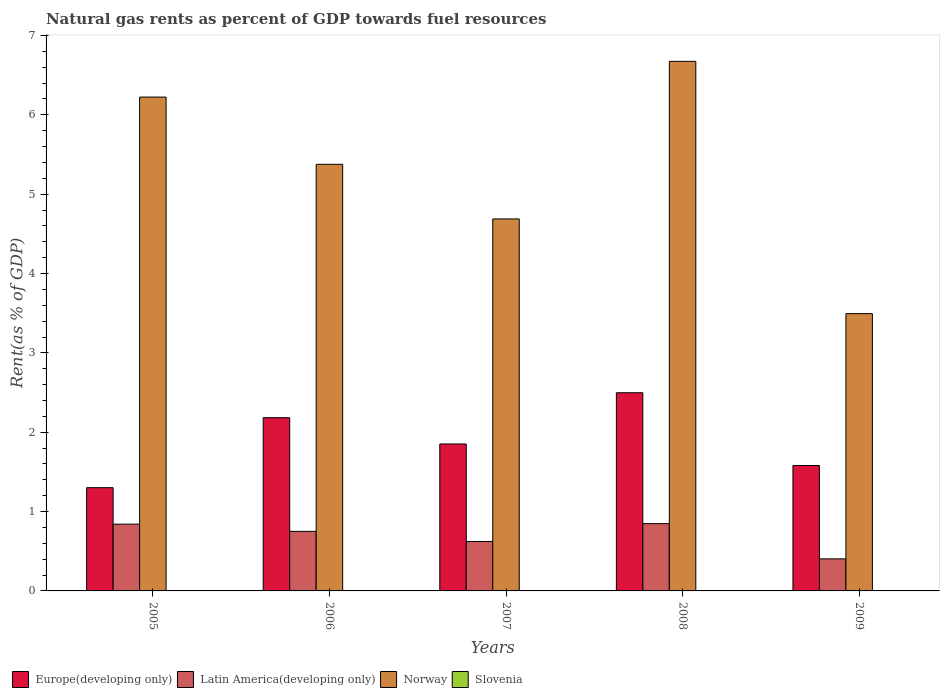How many different coloured bars are there?
Give a very brief answer. 4. How many groups of bars are there?
Offer a terse response. 5. Are the number of bars on each tick of the X-axis equal?
Ensure brevity in your answer.  Yes. What is the label of the 4th group of bars from the left?
Provide a short and direct response. 2008. What is the matural gas rent in Norway in 2008?
Make the answer very short. 6.67. Across all years, what is the maximum matural gas rent in Latin America(developing only)?
Ensure brevity in your answer.  0.85. Across all years, what is the minimum matural gas rent in Latin America(developing only)?
Your answer should be very brief. 0.4. What is the total matural gas rent in Slovenia in the graph?
Make the answer very short. 0.01. What is the difference between the matural gas rent in Norway in 2006 and that in 2008?
Your answer should be compact. -1.3. What is the difference between the matural gas rent in Europe(developing only) in 2008 and the matural gas rent in Slovenia in 2009?
Ensure brevity in your answer.  2.5. What is the average matural gas rent in Latin America(developing only) per year?
Your response must be concise. 0.69. In the year 2009, what is the difference between the matural gas rent in Europe(developing only) and matural gas rent in Latin America(developing only)?
Make the answer very short. 1.18. In how many years, is the matural gas rent in Latin America(developing only) greater than 3.4 %?
Give a very brief answer. 0. What is the ratio of the matural gas rent in Slovenia in 2006 to that in 2007?
Ensure brevity in your answer.  1.64. Is the difference between the matural gas rent in Europe(developing only) in 2006 and 2009 greater than the difference between the matural gas rent in Latin America(developing only) in 2006 and 2009?
Ensure brevity in your answer.  Yes. What is the difference between the highest and the second highest matural gas rent in Europe(developing only)?
Keep it short and to the point. 0.31. What is the difference between the highest and the lowest matural gas rent in Norway?
Keep it short and to the point. 3.18. In how many years, is the matural gas rent in Slovenia greater than the average matural gas rent in Slovenia taken over all years?
Offer a very short reply. 3. Is the sum of the matural gas rent in Latin America(developing only) in 2007 and 2009 greater than the maximum matural gas rent in Europe(developing only) across all years?
Offer a terse response. No. What does the 4th bar from the right in 2009 represents?
Offer a very short reply. Europe(developing only). Is it the case that in every year, the sum of the matural gas rent in Norway and matural gas rent in Slovenia is greater than the matural gas rent in Europe(developing only)?
Offer a terse response. Yes. How many years are there in the graph?
Ensure brevity in your answer.  5. What is the difference between two consecutive major ticks on the Y-axis?
Offer a terse response. 1. Does the graph contain any zero values?
Your response must be concise. No. Does the graph contain grids?
Offer a terse response. No. How are the legend labels stacked?
Provide a succinct answer. Horizontal. What is the title of the graph?
Give a very brief answer. Natural gas rents as percent of GDP towards fuel resources. What is the label or title of the Y-axis?
Your response must be concise. Rent(as % of GDP). What is the Rent(as % of GDP) of Europe(developing only) in 2005?
Offer a terse response. 1.3. What is the Rent(as % of GDP) of Latin America(developing only) in 2005?
Provide a short and direct response. 0.84. What is the Rent(as % of GDP) of Norway in 2005?
Offer a very short reply. 6.22. What is the Rent(as % of GDP) in Slovenia in 2005?
Ensure brevity in your answer.  0. What is the Rent(as % of GDP) in Europe(developing only) in 2006?
Keep it short and to the point. 2.18. What is the Rent(as % of GDP) in Latin America(developing only) in 2006?
Offer a terse response. 0.75. What is the Rent(as % of GDP) of Norway in 2006?
Provide a succinct answer. 5.38. What is the Rent(as % of GDP) of Slovenia in 2006?
Give a very brief answer. 0. What is the Rent(as % of GDP) in Europe(developing only) in 2007?
Keep it short and to the point. 1.85. What is the Rent(as % of GDP) of Latin America(developing only) in 2007?
Provide a succinct answer. 0.62. What is the Rent(as % of GDP) of Norway in 2007?
Your response must be concise. 4.69. What is the Rent(as % of GDP) in Slovenia in 2007?
Your response must be concise. 0. What is the Rent(as % of GDP) of Europe(developing only) in 2008?
Offer a very short reply. 2.5. What is the Rent(as % of GDP) of Latin America(developing only) in 2008?
Provide a succinct answer. 0.85. What is the Rent(as % of GDP) of Norway in 2008?
Your answer should be compact. 6.67. What is the Rent(as % of GDP) of Slovenia in 2008?
Keep it short and to the point. 0. What is the Rent(as % of GDP) of Europe(developing only) in 2009?
Ensure brevity in your answer.  1.58. What is the Rent(as % of GDP) in Latin America(developing only) in 2009?
Offer a terse response. 0.4. What is the Rent(as % of GDP) of Norway in 2009?
Your answer should be very brief. 3.49. What is the Rent(as % of GDP) in Slovenia in 2009?
Provide a short and direct response. 0. Across all years, what is the maximum Rent(as % of GDP) in Europe(developing only)?
Keep it short and to the point. 2.5. Across all years, what is the maximum Rent(as % of GDP) in Latin America(developing only)?
Ensure brevity in your answer.  0.85. Across all years, what is the maximum Rent(as % of GDP) of Norway?
Offer a very short reply. 6.67. Across all years, what is the maximum Rent(as % of GDP) in Slovenia?
Keep it short and to the point. 0. Across all years, what is the minimum Rent(as % of GDP) of Europe(developing only)?
Your answer should be very brief. 1.3. Across all years, what is the minimum Rent(as % of GDP) in Latin America(developing only)?
Your response must be concise. 0.4. Across all years, what is the minimum Rent(as % of GDP) in Norway?
Provide a succinct answer. 3.49. Across all years, what is the minimum Rent(as % of GDP) in Slovenia?
Your response must be concise. 0. What is the total Rent(as % of GDP) in Europe(developing only) in the graph?
Offer a terse response. 9.42. What is the total Rent(as % of GDP) of Latin America(developing only) in the graph?
Provide a short and direct response. 3.47. What is the total Rent(as % of GDP) of Norway in the graph?
Make the answer very short. 26.46. What is the total Rent(as % of GDP) in Slovenia in the graph?
Offer a terse response. 0.01. What is the difference between the Rent(as % of GDP) of Europe(developing only) in 2005 and that in 2006?
Offer a terse response. -0.88. What is the difference between the Rent(as % of GDP) of Latin America(developing only) in 2005 and that in 2006?
Your answer should be compact. 0.09. What is the difference between the Rent(as % of GDP) in Norway in 2005 and that in 2006?
Make the answer very short. 0.85. What is the difference between the Rent(as % of GDP) in Slovenia in 2005 and that in 2006?
Provide a succinct answer. 0. What is the difference between the Rent(as % of GDP) of Europe(developing only) in 2005 and that in 2007?
Your response must be concise. -0.55. What is the difference between the Rent(as % of GDP) in Latin America(developing only) in 2005 and that in 2007?
Offer a terse response. 0.22. What is the difference between the Rent(as % of GDP) of Norway in 2005 and that in 2007?
Ensure brevity in your answer.  1.54. What is the difference between the Rent(as % of GDP) of Slovenia in 2005 and that in 2007?
Your answer should be compact. 0. What is the difference between the Rent(as % of GDP) of Europe(developing only) in 2005 and that in 2008?
Offer a very short reply. -1.2. What is the difference between the Rent(as % of GDP) in Latin America(developing only) in 2005 and that in 2008?
Your answer should be very brief. -0.01. What is the difference between the Rent(as % of GDP) in Norway in 2005 and that in 2008?
Your response must be concise. -0.45. What is the difference between the Rent(as % of GDP) of Slovenia in 2005 and that in 2008?
Ensure brevity in your answer.  0. What is the difference between the Rent(as % of GDP) of Europe(developing only) in 2005 and that in 2009?
Ensure brevity in your answer.  -0.28. What is the difference between the Rent(as % of GDP) in Latin America(developing only) in 2005 and that in 2009?
Provide a succinct answer. 0.44. What is the difference between the Rent(as % of GDP) of Norway in 2005 and that in 2009?
Your answer should be very brief. 2.73. What is the difference between the Rent(as % of GDP) in Slovenia in 2005 and that in 2009?
Provide a short and direct response. 0. What is the difference between the Rent(as % of GDP) of Europe(developing only) in 2006 and that in 2007?
Provide a short and direct response. 0.33. What is the difference between the Rent(as % of GDP) of Latin America(developing only) in 2006 and that in 2007?
Your answer should be very brief. 0.13. What is the difference between the Rent(as % of GDP) in Norway in 2006 and that in 2007?
Offer a very short reply. 0.69. What is the difference between the Rent(as % of GDP) of Slovenia in 2006 and that in 2007?
Your response must be concise. 0. What is the difference between the Rent(as % of GDP) of Europe(developing only) in 2006 and that in 2008?
Make the answer very short. -0.31. What is the difference between the Rent(as % of GDP) in Latin America(developing only) in 2006 and that in 2008?
Your answer should be very brief. -0.1. What is the difference between the Rent(as % of GDP) of Norway in 2006 and that in 2008?
Offer a very short reply. -1.3. What is the difference between the Rent(as % of GDP) in Europe(developing only) in 2006 and that in 2009?
Offer a very short reply. 0.6. What is the difference between the Rent(as % of GDP) in Latin America(developing only) in 2006 and that in 2009?
Offer a terse response. 0.35. What is the difference between the Rent(as % of GDP) in Norway in 2006 and that in 2009?
Your answer should be compact. 1.88. What is the difference between the Rent(as % of GDP) of Slovenia in 2006 and that in 2009?
Offer a very short reply. 0. What is the difference between the Rent(as % of GDP) in Europe(developing only) in 2007 and that in 2008?
Your response must be concise. -0.65. What is the difference between the Rent(as % of GDP) in Latin America(developing only) in 2007 and that in 2008?
Give a very brief answer. -0.23. What is the difference between the Rent(as % of GDP) of Norway in 2007 and that in 2008?
Provide a short and direct response. -1.99. What is the difference between the Rent(as % of GDP) of Slovenia in 2007 and that in 2008?
Give a very brief answer. -0. What is the difference between the Rent(as % of GDP) of Europe(developing only) in 2007 and that in 2009?
Ensure brevity in your answer.  0.27. What is the difference between the Rent(as % of GDP) in Latin America(developing only) in 2007 and that in 2009?
Offer a very short reply. 0.22. What is the difference between the Rent(as % of GDP) in Norway in 2007 and that in 2009?
Provide a succinct answer. 1.19. What is the difference between the Rent(as % of GDP) in Slovenia in 2007 and that in 2009?
Offer a terse response. 0. What is the difference between the Rent(as % of GDP) in Europe(developing only) in 2008 and that in 2009?
Your answer should be very brief. 0.92. What is the difference between the Rent(as % of GDP) of Latin America(developing only) in 2008 and that in 2009?
Offer a very short reply. 0.44. What is the difference between the Rent(as % of GDP) of Norway in 2008 and that in 2009?
Give a very brief answer. 3.18. What is the difference between the Rent(as % of GDP) of Europe(developing only) in 2005 and the Rent(as % of GDP) of Latin America(developing only) in 2006?
Provide a succinct answer. 0.55. What is the difference between the Rent(as % of GDP) of Europe(developing only) in 2005 and the Rent(as % of GDP) of Norway in 2006?
Offer a very short reply. -4.08. What is the difference between the Rent(as % of GDP) of Europe(developing only) in 2005 and the Rent(as % of GDP) of Slovenia in 2006?
Make the answer very short. 1.3. What is the difference between the Rent(as % of GDP) of Latin America(developing only) in 2005 and the Rent(as % of GDP) of Norway in 2006?
Your response must be concise. -4.54. What is the difference between the Rent(as % of GDP) in Latin America(developing only) in 2005 and the Rent(as % of GDP) in Slovenia in 2006?
Give a very brief answer. 0.84. What is the difference between the Rent(as % of GDP) of Norway in 2005 and the Rent(as % of GDP) of Slovenia in 2006?
Your response must be concise. 6.22. What is the difference between the Rent(as % of GDP) in Europe(developing only) in 2005 and the Rent(as % of GDP) in Latin America(developing only) in 2007?
Keep it short and to the point. 0.68. What is the difference between the Rent(as % of GDP) of Europe(developing only) in 2005 and the Rent(as % of GDP) of Norway in 2007?
Offer a very short reply. -3.39. What is the difference between the Rent(as % of GDP) of Europe(developing only) in 2005 and the Rent(as % of GDP) of Slovenia in 2007?
Make the answer very short. 1.3. What is the difference between the Rent(as % of GDP) of Latin America(developing only) in 2005 and the Rent(as % of GDP) of Norway in 2007?
Make the answer very short. -3.85. What is the difference between the Rent(as % of GDP) of Latin America(developing only) in 2005 and the Rent(as % of GDP) of Slovenia in 2007?
Keep it short and to the point. 0.84. What is the difference between the Rent(as % of GDP) of Norway in 2005 and the Rent(as % of GDP) of Slovenia in 2007?
Provide a short and direct response. 6.22. What is the difference between the Rent(as % of GDP) in Europe(developing only) in 2005 and the Rent(as % of GDP) in Latin America(developing only) in 2008?
Offer a very short reply. 0.45. What is the difference between the Rent(as % of GDP) in Europe(developing only) in 2005 and the Rent(as % of GDP) in Norway in 2008?
Your answer should be very brief. -5.37. What is the difference between the Rent(as % of GDP) of Europe(developing only) in 2005 and the Rent(as % of GDP) of Slovenia in 2008?
Offer a terse response. 1.3. What is the difference between the Rent(as % of GDP) in Latin America(developing only) in 2005 and the Rent(as % of GDP) in Norway in 2008?
Keep it short and to the point. -5.83. What is the difference between the Rent(as % of GDP) of Latin America(developing only) in 2005 and the Rent(as % of GDP) of Slovenia in 2008?
Make the answer very short. 0.84. What is the difference between the Rent(as % of GDP) of Norway in 2005 and the Rent(as % of GDP) of Slovenia in 2008?
Offer a terse response. 6.22. What is the difference between the Rent(as % of GDP) of Europe(developing only) in 2005 and the Rent(as % of GDP) of Latin America(developing only) in 2009?
Make the answer very short. 0.9. What is the difference between the Rent(as % of GDP) of Europe(developing only) in 2005 and the Rent(as % of GDP) of Norway in 2009?
Provide a short and direct response. -2.19. What is the difference between the Rent(as % of GDP) in Europe(developing only) in 2005 and the Rent(as % of GDP) in Slovenia in 2009?
Provide a succinct answer. 1.3. What is the difference between the Rent(as % of GDP) of Latin America(developing only) in 2005 and the Rent(as % of GDP) of Norway in 2009?
Make the answer very short. -2.65. What is the difference between the Rent(as % of GDP) of Latin America(developing only) in 2005 and the Rent(as % of GDP) of Slovenia in 2009?
Your response must be concise. 0.84. What is the difference between the Rent(as % of GDP) of Norway in 2005 and the Rent(as % of GDP) of Slovenia in 2009?
Your answer should be very brief. 6.22. What is the difference between the Rent(as % of GDP) in Europe(developing only) in 2006 and the Rent(as % of GDP) in Latin America(developing only) in 2007?
Keep it short and to the point. 1.56. What is the difference between the Rent(as % of GDP) of Europe(developing only) in 2006 and the Rent(as % of GDP) of Norway in 2007?
Ensure brevity in your answer.  -2.5. What is the difference between the Rent(as % of GDP) in Europe(developing only) in 2006 and the Rent(as % of GDP) in Slovenia in 2007?
Ensure brevity in your answer.  2.18. What is the difference between the Rent(as % of GDP) in Latin America(developing only) in 2006 and the Rent(as % of GDP) in Norway in 2007?
Your response must be concise. -3.94. What is the difference between the Rent(as % of GDP) in Latin America(developing only) in 2006 and the Rent(as % of GDP) in Slovenia in 2007?
Offer a very short reply. 0.75. What is the difference between the Rent(as % of GDP) in Norway in 2006 and the Rent(as % of GDP) in Slovenia in 2007?
Offer a terse response. 5.38. What is the difference between the Rent(as % of GDP) of Europe(developing only) in 2006 and the Rent(as % of GDP) of Latin America(developing only) in 2008?
Your answer should be very brief. 1.34. What is the difference between the Rent(as % of GDP) in Europe(developing only) in 2006 and the Rent(as % of GDP) in Norway in 2008?
Offer a very short reply. -4.49. What is the difference between the Rent(as % of GDP) in Europe(developing only) in 2006 and the Rent(as % of GDP) in Slovenia in 2008?
Provide a short and direct response. 2.18. What is the difference between the Rent(as % of GDP) of Latin America(developing only) in 2006 and the Rent(as % of GDP) of Norway in 2008?
Offer a very short reply. -5.92. What is the difference between the Rent(as % of GDP) of Latin America(developing only) in 2006 and the Rent(as % of GDP) of Slovenia in 2008?
Keep it short and to the point. 0.75. What is the difference between the Rent(as % of GDP) of Norway in 2006 and the Rent(as % of GDP) of Slovenia in 2008?
Make the answer very short. 5.37. What is the difference between the Rent(as % of GDP) of Europe(developing only) in 2006 and the Rent(as % of GDP) of Latin America(developing only) in 2009?
Provide a short and direct response. 1.78. What is the difference between the Rent(as % of GDP) in Europe(developing only) in 2006 and the Rent(as % of GDP) in Norway in 2009?
Give a very brief answer. -1.31. What is the difference between the Rent(as % of GDP) in Europe(developing only) in 2006 and the Rent(as % of GDP) in Slovenia in 2009?
Your answer should be very brief. 2.18. What is the difference between the Rent(as % of GDP) in Latin America(developing only) in 2006 and the Rent(as % of GDP) in Norway in 2009?
Give a very brief answer. -2.74. What is the difference between the Rent(as % of GDP) of Latin America(developing only) in 2006 and the Rent(as % of GDP) of Slovenia in 2009?
Provide a succinct answer. 0.75. What is the difference between the Rent(as % of GDP) in Norway in 2006 and the Rent(as % of GDP) in Slovenia in 2009?
Make the answer very short. 5.38. What is the difference between the Rent(as % of GDP) of Europe(developing only) in 2007 and the Rent(as % of GDP) of Norway in 2008?
Make the answer very short. -4.82. What is the difference between the Rent(as % of GDP) in Europe(developing only) in 2007 and the Rent(as % of GDP) in Slovenia in 2008?
Your response must be concise. 1.85. What is the difference between the Rent(as % of GDP) in Latin America(developing only) in 2007 and the Rent(as % of GDP) in Norway in 2008?
Provide a short and direct response. -6.05. What is the difference between the Rent(as % of GDP) in Latin America(developing only) in 2007 and the Rent(as % of GDP) in Slovenia in 2008?
Keep it short and to the point. 0.62. What is the difference between the Rent(as % of GDP) in Norway in 2007 and the Rent(as % of GDP) in Slovenia in 2008?
Provide a succinct answer. 4.69. What is the difference between the Rent(as % of GDP) in Europe(developing only) in 2007 and the Rent(as % of GDP) in Latin America(developing only) in 2009?
Provide a succinct answer. 1.45. What is the difference between the Rent(as % of GDP) of Europe(developing only) in 2007 and the Rent(as % of GDP) of Norway in 2009?
Your answer should be compact. -1.64. What is the difference between the Rent(as % of GDP) in Europe(developing only) in 2007 and the Rent(as % of GDP) in Slovenia in 2009?
Your answer should be very brief. 1.85. What is the difference between the Rent(as % of GDP) of Latin America(developing only) in 2007 and the Rent(as % of GDP) of Norway in 2009?
Provide a succinct answer. -2.87. What is the difference between the Rent(as % of GDP) in Latin America(developing only) in 2007 and the Rent(as % of GDP) in Slovenia in 2009?
Make the answer very short. 0.62. What is the difference between the Rent(as % of GDP) in Norway in 2007 and the Rent(as % of GDP) in Slovenia in 2009?
Give a very brief answer. 4.69. What is the difference between the Rent(as % of GDP) of Europe(developing only) in 2008 and the Rent(as % of GDP) of Latin America(developing only) in 2009?
Offer a very short reply. 2.09. What is the difference between the Rent(as % of GDP) in Europe(developing only) in 2008 and the Rent(as % of GDP) in Norway in 2009?
Give a very brief answer. -1. What is the difference between the Rent(as % of GDP) of Europe(developing only) in 2008 and the Rent(as % of GDP) of Slovenia in 2009?
Make the answer very short. 2.5. What is the difference between the Rent(as % of GDP) of Latin America(developing only) in 2008 and the Rent(as % of GDP) of Norway in 2009?
Your answer should be very brief. -2.65. What is the difference between the Rent(as % of GDP) of Latin America(developing only) in 2008 and the Rent(as % of GDP) of Slovenia in 2009?
Give a very brief answer. 0.85. What is the difference between the Rent(as % of GDP) of Norway in 2008 and the Rent(as % of GDP) of Slovenia in 2009?
Your response must be concise. 6.67. What is the average Rent(as % of GDP) in Europe(developing only) per year?
Offer a terse response. 1.88. What is the average Rent(as % of GDP) in Latin America(developing only) per year?
Make the answer very short. 0.69. What is the average Rent(as % of GDP) in Norway per year?
Keep it short and to the point. 5.29. What is the average Rent(as % of GDP) of Slovenia per year?
Ensure brevity in your answer.  0. In the year 2005, what is the difference between the Rent(as % of GDP) in Europe(developing only) and Rent(as % of GDP) in Latin America(developing only)?
Your answer should be compact. 0.46. In the year 2005, what is the difference between the Rent(as % of GDP) in Europe(developing only) and Rent(as % of GDP) in Norway?
Offer a very short reply. -4.92. In the year 2005, what is the difference between the Rent(as % of GDP) in Europe(developing only) and Rent(as % of GDP) in Slovenia?
Offer a terse response. 1.3. In the year 2005, what is the difference between the Rent(as % of GDP) of Latin America(developing only) and Rent(as % of GDP) of Norway?
Make the answer very short. -5.38. In the year 2005, what is the difference between the Rent(as % of GDP) of Latin America(developing only) and Rent(as % of GDP) of Slovenia?
Keep it short and to the point. 0.84. In the year 2005, what is the difference between the Rent(as % of GDP) of Norway and Rent(as % of GDP) of Slovenia?
Ensure brevity in your answer.  6.22. In the year 2006, what is the difference between the Rent(as % of GDP) of Europe(developing only) and Rent(as % of GDP) of Latin America(developing only)?
Ensure brevity in your answer.  1.43. In the year 2006, what is the difference between the Rent(as % of GDP) of Europe(developing only) and Rent(as % of GDP) of Norway?
Provide a short and direct response. -3.19. In the year 2006, what is the difference between the Rent(as % of GDP) of Europe(developing only) and Rent(as % of GDP) of Slovenia?
Your answer should be compact. 2.18. In the year 2006, what is the difference between the Rent(as % of GDP) of Latin America(developing only) and Rent(as % of GDP) of Norway?
Your answer should be compact. -4.63. In the year 2006, what is the difference between the Rent(as % of GDP) of Latin America(developing only) and Rent(as % of GDP) of Slovenia?
Keep it short and to the point. 0.75. In the year 2006, what is the difference between the Rent(as % of GDP) of Norway and Rent(as % of GDP) of Slovenia?
Offer a terse response. 5.37. In the year 2007, what is the difference between the Rent(as % of GDP) of Europe(developing only) and Rent(as % of GDP) of Latin America(developing only)?
Offer a terse response. 1.23. In the year 2007, what is the difference between the Rent(as % of GDP) of Europe(developing only) and Rent(as % of GDP) of Norway?
Offer a terse response. -2.84. In the year 2007, what is the difference between the Rent(as % of GDP) in Europe(developing only) and Rent(as % of GDP) in Slovenia?
Give a very brief answer. 1.85. In the year 2007, what is the difference between the Rent(as % of GDP) in Latin America(developing only) and Rent(as % of GDP) in Norway?
Ensure brevity in your answer.  -4.06. In the year 2007, what is the difference between the Rent(as % of GDP) in Latin America(developing only) and Rent(as % of GDP) in Slovenia?
Provide a short and direct response. 0.62. In the year 2007, what is the difference between the Rent(as % of GDP) of Norway and Rent(as % of GDP) of Slovenia?
Your answer should be very brief. 4.69. In the year 2008, what is the difference between the Rent(as % of GDP) in Europe(developing only) and Rent(as % of GDP) in Latin America(developing only)?
Ensure brevity in your answer.  1.65. In the year 2008, what is the difference between the Rent(as % of GDP) in Europe(developing only) and Rent(as % of GDP) in Norway?
Ensure brevity in your answer.  -4.18. In the year 2008, what is the difference between the Rent(as % of GDP) in Europe(developing only) and Rent(as % of GDP) in Slovenia?
Your answer should be very brief. 2.5. In the year 2008, what is the difference between the Rent(as % of GDP) of Latin America(developing only) and Rent(as % of GDP) of Norway?
Provide a short and direct response. -5.83. In the year 2008, what is the difference between the Rent(as % of GDP) in Latin America(developing only) and Rent(as % of GDP) in Slovenia?
Offer a very short reply. 0.85. In the year 2008, what is the difference between the Rent(as % of GDP) of Norway and Rent(as % of GDP) of Slovenia?
Your answer should be very brief. 6.67. In the year 2009, what is the difference between the Rent(as % of GDP) in Europe(developing only) and Rent(as % of GDP) in Latin America(developing only)?
Keep it short and to the point. 1.18. In the year 2009, what is the difference between the Rent(as % of GDP) of Europe(developing only) and Rent(as % of GDP) of Norway?
Keep it short and to the point. -1.91. In the year 2009, what is the difference between the Rent(as % of GDP) of Europe(developing only) and Rent(as % of GDP) of Slovenia?
Your answer should be very brief. 1.58. In the year 2009, what is the difference between the Rent(as % of GDP) of Latin America(developing only) and Rent(as % of GDP) of Norway?
Offer a terse response. -3.09. In the year 2009, what is the difference between the Rent(as % of GDP) of Latin America(developing only) and Rent(as % of GDP) of Slovenia?
Keep it short and to the point. 0.4. In the year 2009, what is the difference between the Rent(as % of GDP) in Norway and Rent(as % of GDP) in Slovenia?
Give a very brief answer. 3.49. What is the ratio of the Rent(as % of GDP) in Europe(developing only) in 2005 to that in 2006?
Make the answer very short. 0.6. What is the ratio of the Rent(as % of GDP) in Latin America(developing only) in 2005 to that in 2006?
Give a very brief answer. 1.12. What is the ratio of the Rent(as % of GDP) of Norway in 2005 to that in 2006?
Give a very brief answer. 1.16. What is the ratio of the Rent(as % of GDP) of Slovenia in 2005 to that in 2006?
Make the answer very short. 1.13. What is the ratio of the Rent(as % of GDP) of Europe(developing only) in 2005 to that in 2007?
Give a very brief answer. 0.7. What is the ratio of the Rent(as % of GDP) in Latin America(developing only) in 2005 to that in 2007?
Provide a succinct answer. 1.35. What is the ratio of the Rent(as % of GDP) in Norway in 2005 to that in 2007?
Provide a short and direct response. 1.33. What is the ratio of the Rent(as % of GDP) of Slovenia in 2005 to that in 2007?
Keep it short and to the point. 1.86. What is the ratio of the Rent(as % of GDP) in Europe(developing only) in 2005 to that in 2008?
Make the answer very short. 0.52. What is the ratio of the Rent(as % of GDP) of Latin America(developing only) in 2005 to that in 2008?
Your response must be concise. 0.99. What is the ratio of the Rent(as % of GDP) of Norway in 2005 to that in 2008?
Provide a short and direct response. 0.93. What is the ratio of the Rent(as % of GDP) of Slovenia in 2005 to that in 2008?
Offer a terse response. 1.45. What is the ratio of the Rent(as % of GDP) in Europe(developing only) in 2005 to that in 2009?
Your answer should be compact. 0.82. What is the ratio of the Rent(as % of GDP) in Latin America(developing only) in 2005 to that in 2009?
Make the answer very short. 2.08. What is the ratio of the Rent(as % of GDP) in Norway in 2005 to that in 2009?
Provide a succinct answer. 1.78. What is the ratio of the Rent(as % of GDP) of Slovenia in 2005 to that in 2009?
Keep it short and to the point. 3.13. What is the ratio of the Rent(as % of GDP) in Europe(developing only) in 2006 to that in 2007?
Your response must be concise. 1.18. What is the ratio of the Rent(as % of GDP) of Latin America(developing only) in 2006 to that in 2007?
Your answer should be very brief. 1.2. What is the ratio of the Rent(as % of GDP) in Norway in 2006 to that in 2007?
Keep it short and to the point. 1.15. What is the ratio of the Rent(as % of GDP) of Slovenia in 2006 to that in 2007?
Ensure brevity in your answer.  1.64. What is the ratio of the Rent(as % of GDP) in Europe(developing only) in 2006 to that in 2008?
Your answer should be compact. 0.87. What is the ratio of the Rent(as % of GDP) of Latin America(developing only) in 2006 to that in 2008?
Ensure brevity in your answer.  0.88. What is the ratio of the Rent(as % of GDP) of Norway in 2006 to that in 2008?
Ensure brevity in your answer.  0.81. What is the ratio of the Rent(as % of GDP) of Slovenia in 2006 to that in 2008?
Offer a terse response. 1.28. What is the ratio of the Rent(as % of GDP) of Europe(developing only) in 2006 to that in 2009?
Your answer should be compact. 1.38. What is the ratio of the Rent(as % of GDP) in Latin America(developing only) in 2006 to that in 2009?
Give a very brief answer. 1.86. What is the ratio of the Rent(as % of GDP) in Norway in 2006 to that in 2009?
Provide a short and direct response. 1.54. What is the ratio of the Rent(as % of GDP) in Slovenia in 2006 to that in 2009?
Provide a short and direct response. 2.76. What is the ratio of the Rent(as % of GDP) of Europe(developing only) in 2007 to that in 2008?
Provide a short and direct response. 0.74. What is the ratio of the Rent(as % of GDP) of Latin America(developing only) in 2007 to that in 2008?
Make the answer very short. 0.73. What is the ratio of the Rent(as % of GDP) of Norway in 2007 to that in 2008?
Provide a short and direct response. 0.7. What is the ratio of the Rent(as % of GDP) of Slovenia in 2007 to that in 2008?
Provide a short and direct response. 0.78. What is the ratio of the Rent(as % of GDP) of Europe(developing only) in 2007 to that in 2009?
Your response must be concise. 1.17. What is the ratio of the Rent(as % of GDP) of Latin America(developing only) in 2007 to that in 2009?
Give a very brief answer. 1.54. What is the ratio of the Rent(as % of GDP) of Norway in 2007 to that in 2009?
Your answer should be compact. 1.34. What is the ratio of the Rent(as % of GDP) in Slovenia in 2007 to that in 2009?
Make the answer very short. 1.68. What is the ratio of the Rent(as % of GDP) in Europe(developing only) in 2008 to that in 2009?
Provide a short and direct response. 1.58. What is the ratio of the Rent(as % of GDP) in Latin America(developing only) in 2008 to that in 2009?
Your answer should be compact. 2.1. What is the ratio of the Rent(as % of GDP) of Norway in 2008 to that in 2009?
Ensure brevity in your answer.  1.91. What is the ratio of the Rent(as % of GDP) in Slovenia in 2008 to that in 2009?
Your answer should be very brief. 2.16. What is the difference between the highest and the second highest Rent(as % of GDP) of Europe(developing only)?
Your answer should be very brief. 0.31. What is the difference between the highest and the second highest Rent(as % of GDP) of Latin America(developing only)?
Your answer should be very brief. 0.01. What is the difference between the highest and the second highest Rent(as % of GDP) of Norway?
Ensure brevity in your answer.  0.45. What is the difference between the highest and the second highest Rent(as % of GDP) of Slovenia?
Provide a short and direct response. 0. What is the difference between the highest and the lowest Rent(as % of GDP) of Europe(developing only)?
Your answer should be compact. 1.2. What is the difference between the highest and the lowest Rent(as % of GDP) in Latin America(developing only)?
Your answer should be very brief. 0.44. What is the difference between the highest and the lowest Rent(as % of GDP) in Norway?
Offer a very short reply. 3.18. What is the difference between the highest and the lowest Rent(as % of GDP) of Slovenia?
Make the answer very short. 0. 